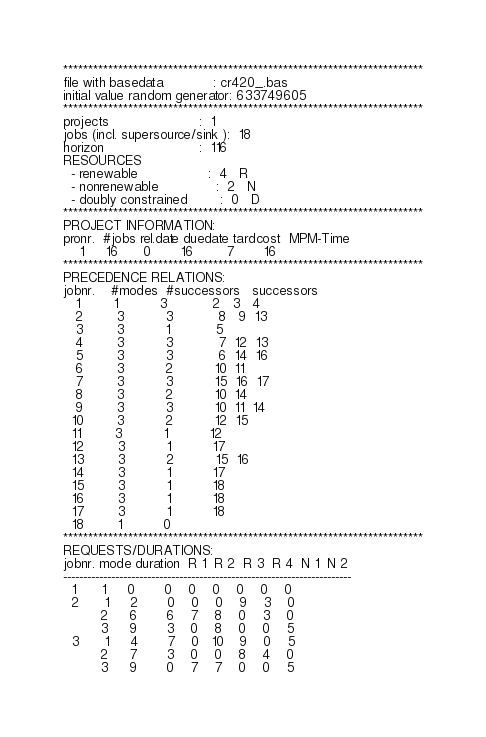<code> <loc_0><loc_0><loc_500><loc_500><_ObjectiveC_>************************************************************************
file with basedata            : cr420_.bas
initial value random generator: 633749605
************************************************************************
projects                      :  1
jobs (incl. supersource/sink ):  18
horizon                       :  116
RESOURCES
  - renewable                 :  4   R
  - nonrenewable              :  2   N
  - doubly constrained        :  0   D
************************************************************************
PROJECT INFORMATION:
pronr.  #jobs rel.date duedate tardcost  MPM-Time
    1     16      0       16        7       16
************************************************************************
PRECEDENCE RELATIONS:
jobnr.    #modes  #successors   successors
   1        1          3           2   3   4
   2        3          3           8   9  13
   3        3          1           5
   4        3          3           7  12  13
   5        3          3           6  14  16
   6        3          2          10  11
   7        3          3          15  16  17
   8        3          2          10  14
   9        3          3          10  11  14
  10        3          2          12  15
  11        3          1          12
  12        3          1          17
  13        3          2          15  16
  14        3          1          17
  15        3          1          18
  16        3          1          18
  17        3          1          18
  18        1          0        
************************************************************************
REQUESTS/DURATIONS:
jobnr. mode duration  R 1  R 2  R 3  R 4  N 1  N 2
------------------------------------------------------------------------
  1      1     0       0    0    0    0    0    0
  2      1     2       0    0    0    9    3    0
         2     6       6    7    8    0    3    0
         3     9       3    0    8    0    0    5
  3      1     4       7    0   10    9    0    5
         2     7       3    0    0    8    4    0
         3     9       0    7    7    0    0    5</code> 